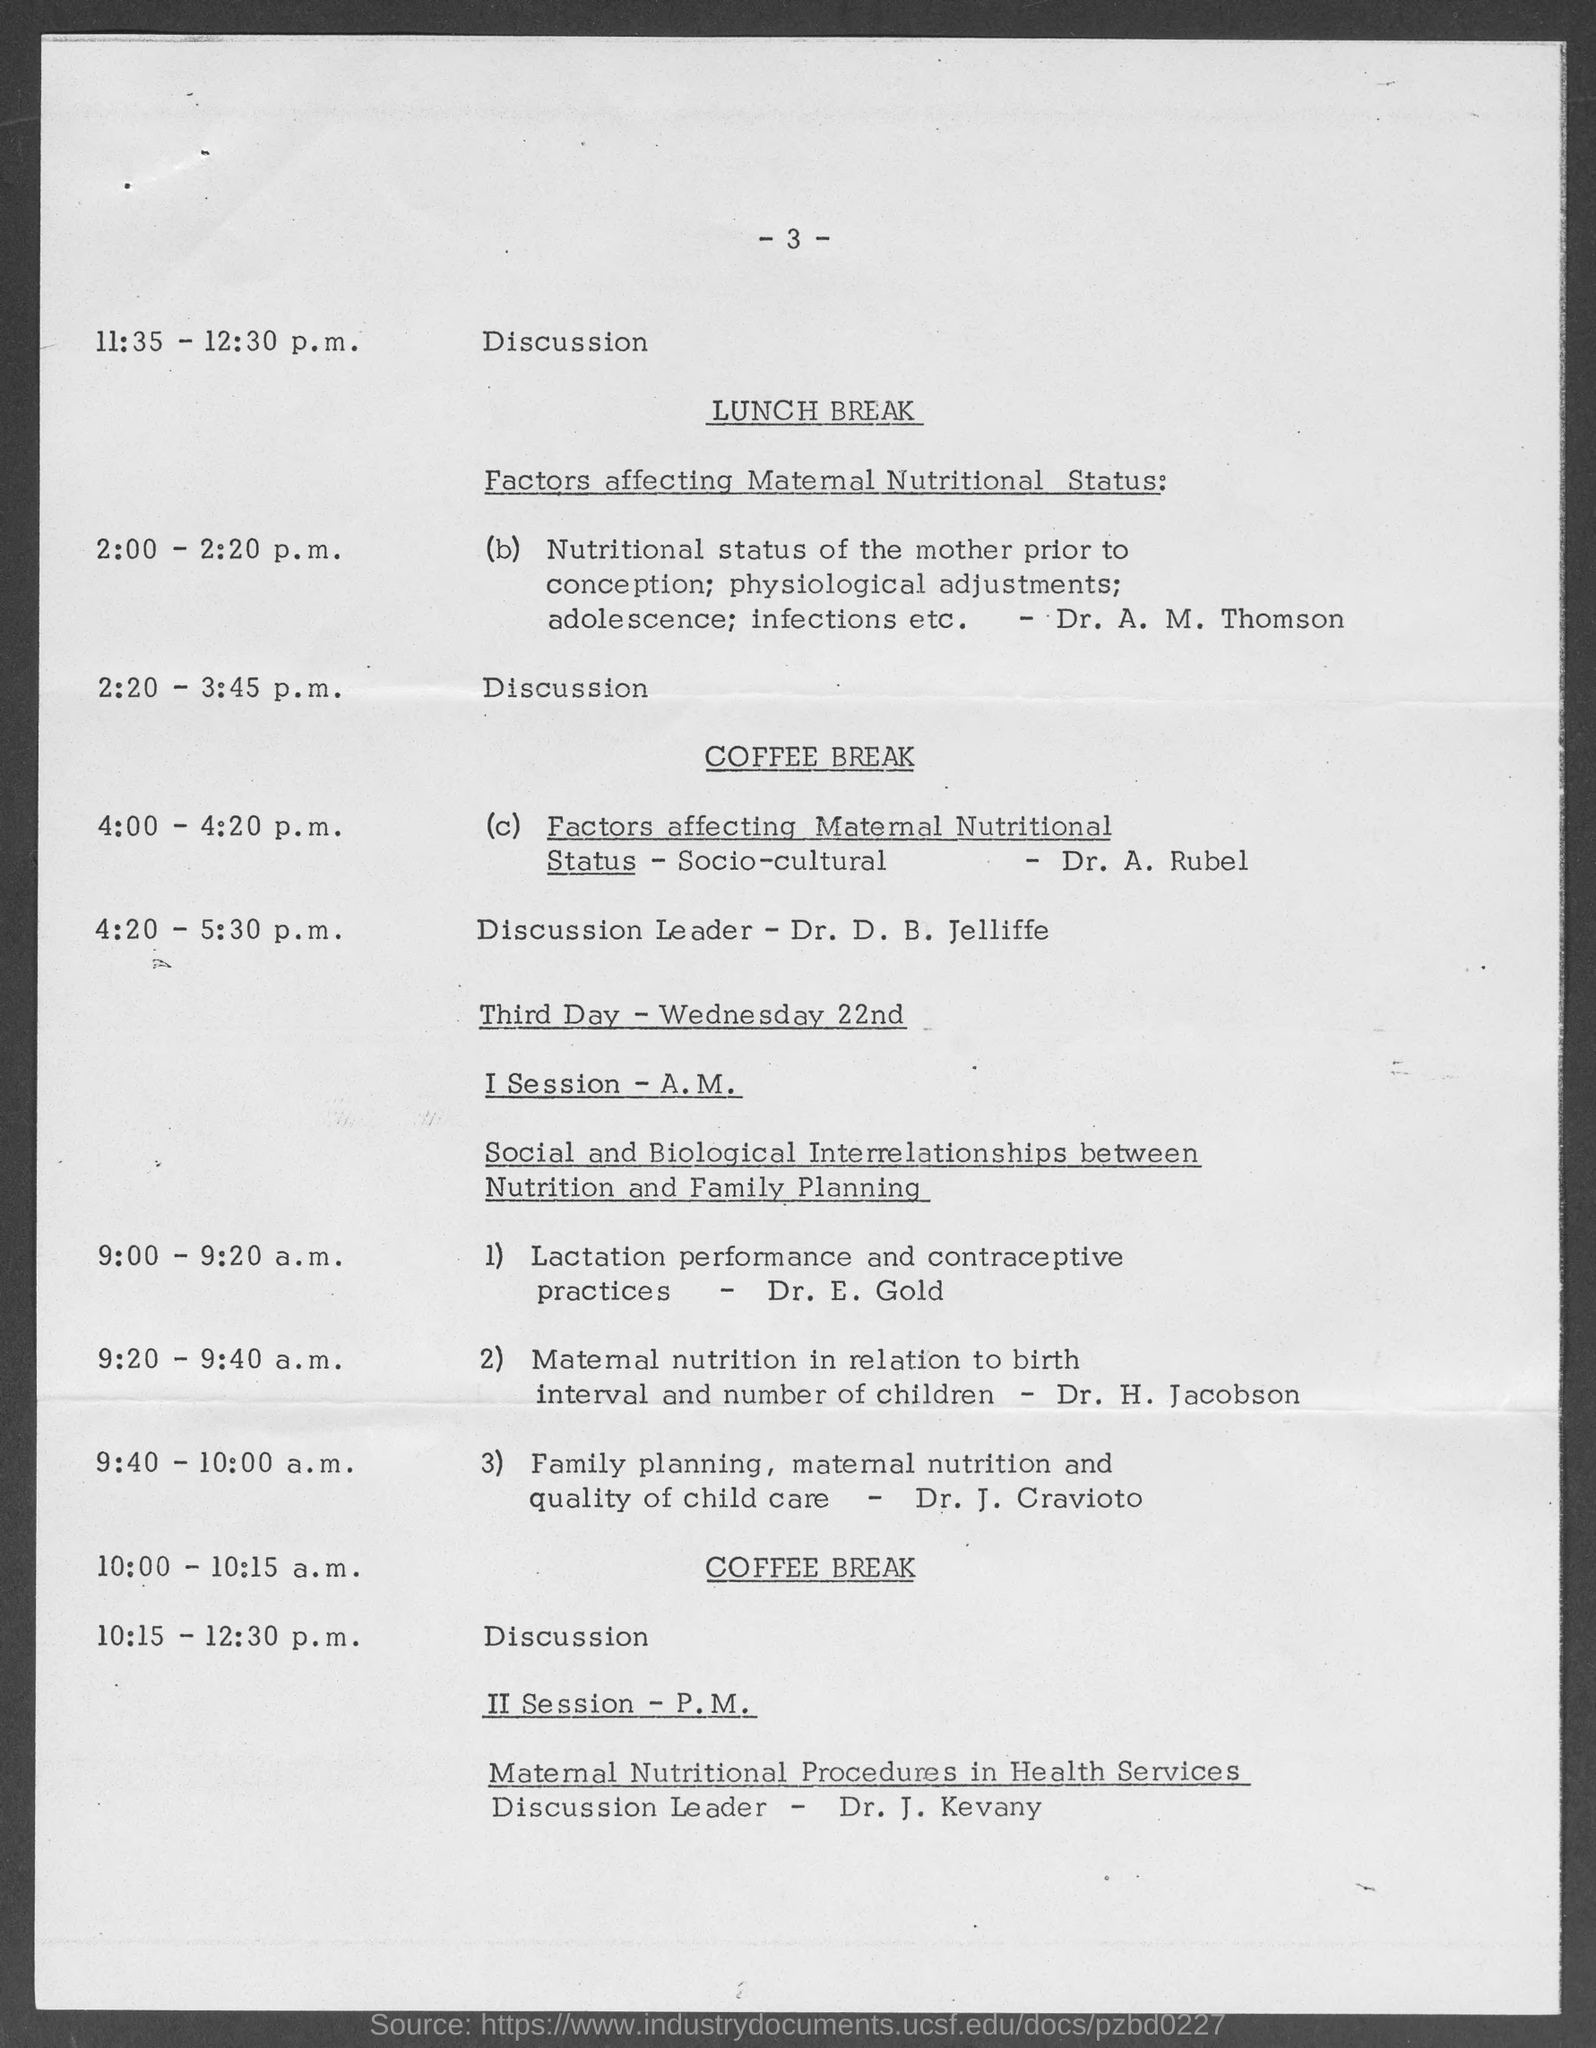Draw attention to some important aspects in this diagram. The paper on the topic "Maternal nutrition in relation to birth interval and number of children" was conducted by Dr. H. Jacobson. Dr. A. M. Thomson conducted a paper on the topic of "Nutritional Status of the mother prior to conception; physiological adjustments;adolescence;infections etc. The coffee break is scheduled to occur from 10:00-10:15 a.m. The discussion leader for the topic "Maternal Nutritional Procedures in Health Services" is Dr. J. Kevany. The paper on the topic "Lactation performance and contraceptive practices" was conducted by Dr. E. Gold. 